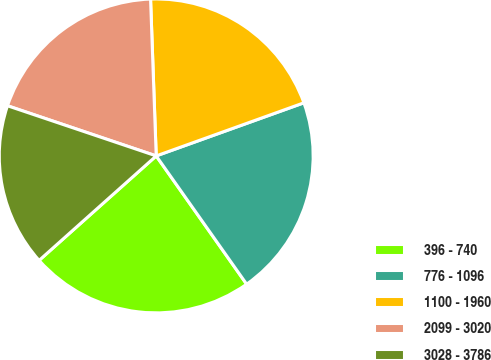Convert chart. <chart><loc_0><loc_0><loc_500><loc_500><pie_chart><fcel>396 - 740<fcel>776 - 1096<fcel>1100 - 1960<fcel>2099 - 3020<fcel>3028 - 3786<nl><fcel>23.18%<fcel>20.72%<fcel>20.08%<fcel>19.25%<fcel>16.77%<nl></chart> 